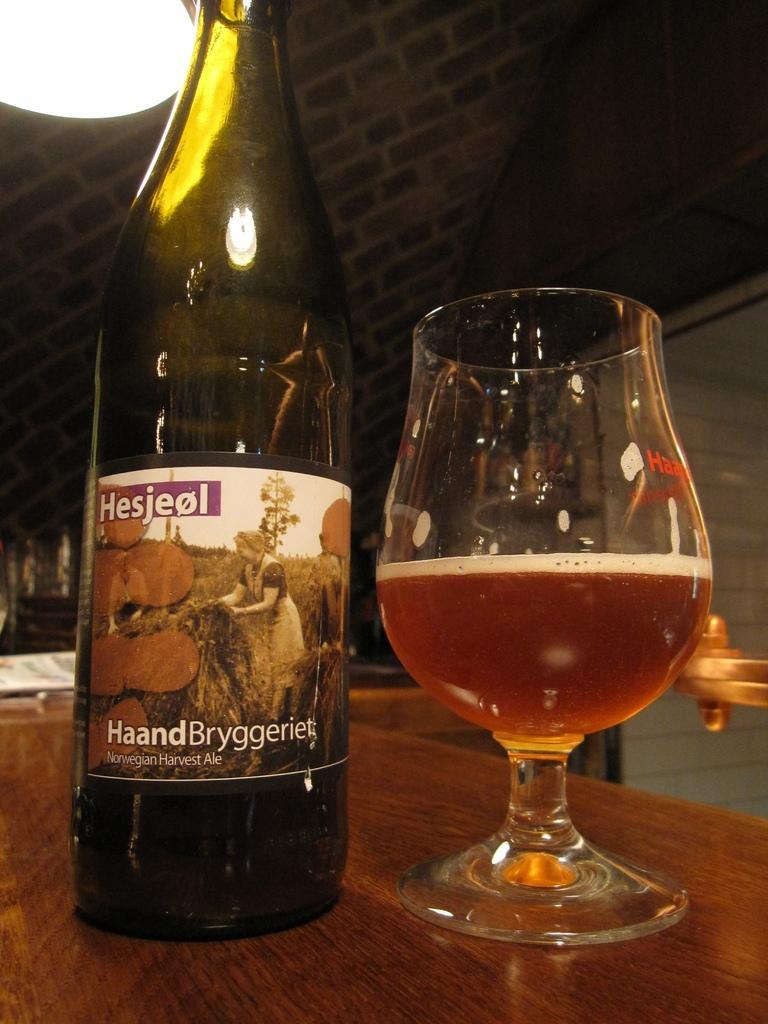Can you describe this image briefly? In this image we can see a table and on the table there are glass tumbler with beverage in it and a beverage bottle. 